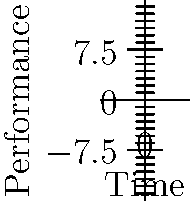Based on the performance curves of three encryption algorithms shown in the graph, which algorithm would you recommend for implementation in a cross-border digital security system that prioritizes efficiency in the long term? Justify your answer considering the trade-offs between initial performance and scalability. To answer this question, we need to analyze the performance curves of the three algorithms over time:

1. Algorithm A (blue curve):
   - Starts with moderate performance
   - Shows steady improvement over time
   - Exhibits the best long-term performance

2. Algorithm B (red curve):
   - Has the best initial performance
   - Improvement rate slows down over time
   - Ends up with the lowest performance in the long run

3. Algorithm C (green curve):
   - Starts with the lowest initial performance
   - Shows the steepest improvement rate
   - Reaches a high performance level, but not as high as Algorithm A in the long term

For a cross-border digital security system, long-term efficiency is crucial. While Algorithm B offers the best initial performance, its efficiency gain slows down significantly over time. Algorithm C shows rapid improvement but doesn't reach the same level of efficiency as Algorithm A in the long run.

Algorithm A, despite starting with moderate performance, demonstrates consistent improvement and achieves the highest efficiency in the long term. This makes it the most suitable choice for a system that requires sustained performance over an extended period.

In the context of cross-border digital security initiatives, the ability to scale and improve over time is essential. Algorithm A's performance curve suggests it has the best potential for adapting to increasing computational demands and evolving security threats.
Answer: Algorithm A, due to its superior long-term performance and consistent improvement rate. 